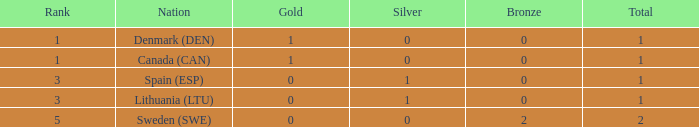How many bronze medals were won when the total is more than 1, and gold is more than 0? None. 